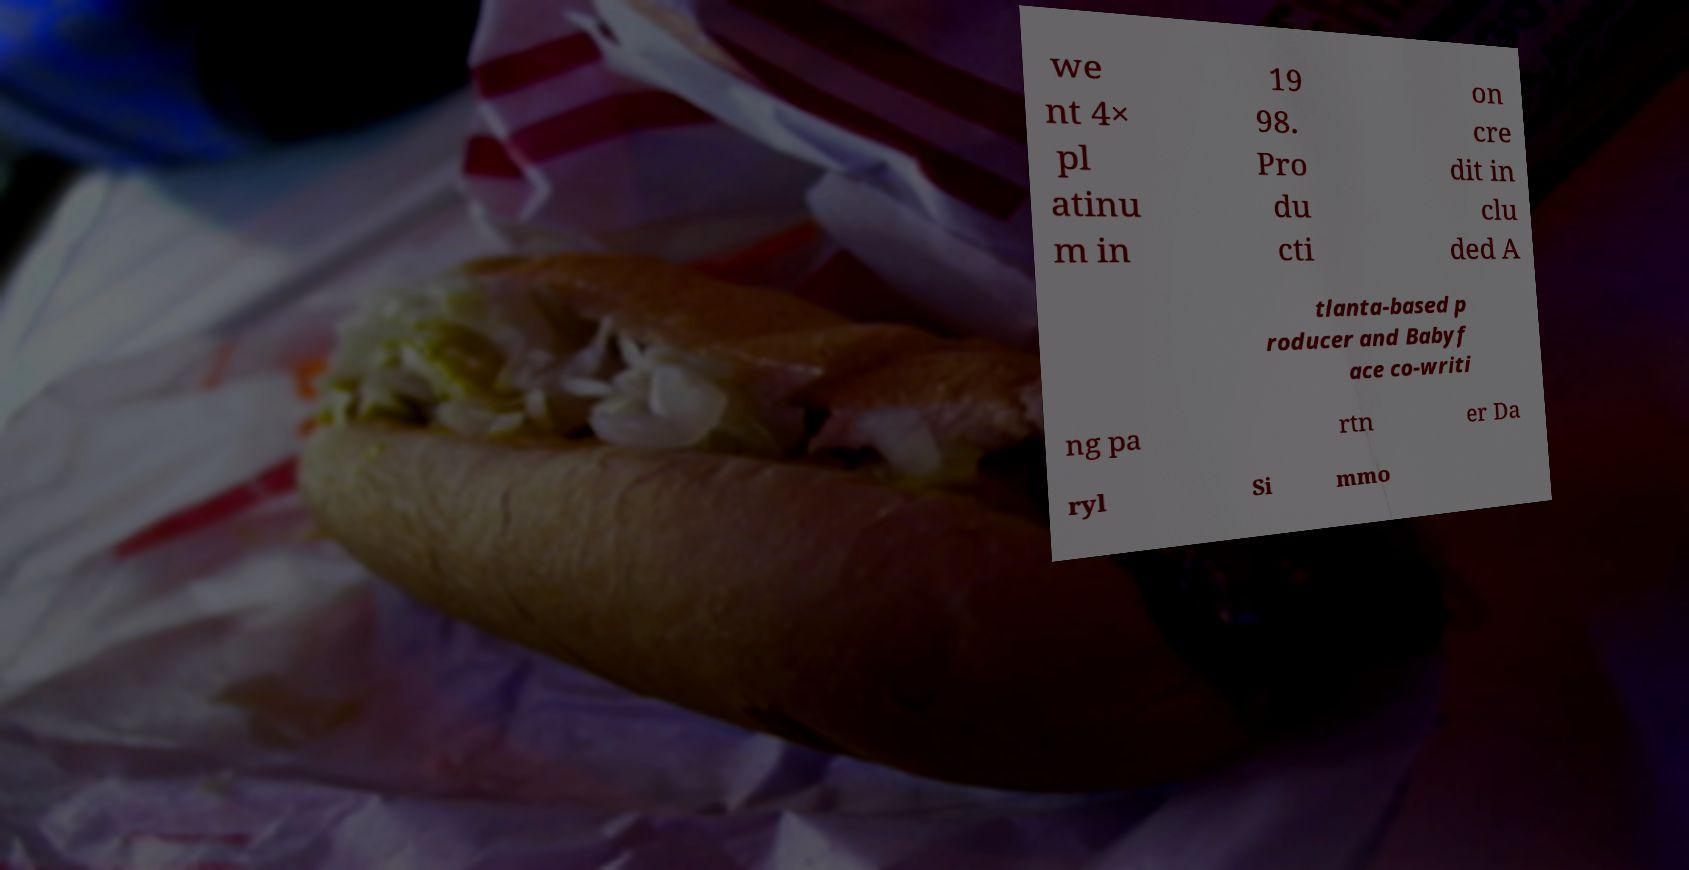There's text embedded in this image that I need extracted. Can you transcribe it verbatim? we nt 4× pl atinu m in 19 98. Pro du cti on cre dit in clu ded A tlanta-based p roducer and Babyf ace co-writi ng pa rtn er Da ryl Si mmo 